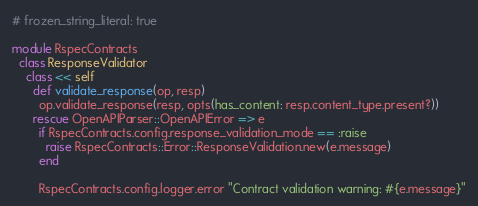<code> <loc_0><loc_0><loc_500><loc_500><_Ruby_># frozen_string_literal: true

module RspecContracts
  class ResponseValidator
    class << self
      def validate_response(op, resp)
        op.validate_response(resp, opts(has_content: resp.content_type.present?))
      rescue OpenAPIParser::OpenAPIError => e
        if RspecContracts.config.response_validation_mode == :raise
          raise RspecContracts::Error::ResponseValidation.new(e.message)
        end

        RspecContracts.config.logger.error "Contract validation warning: #{e.message}"</code> 